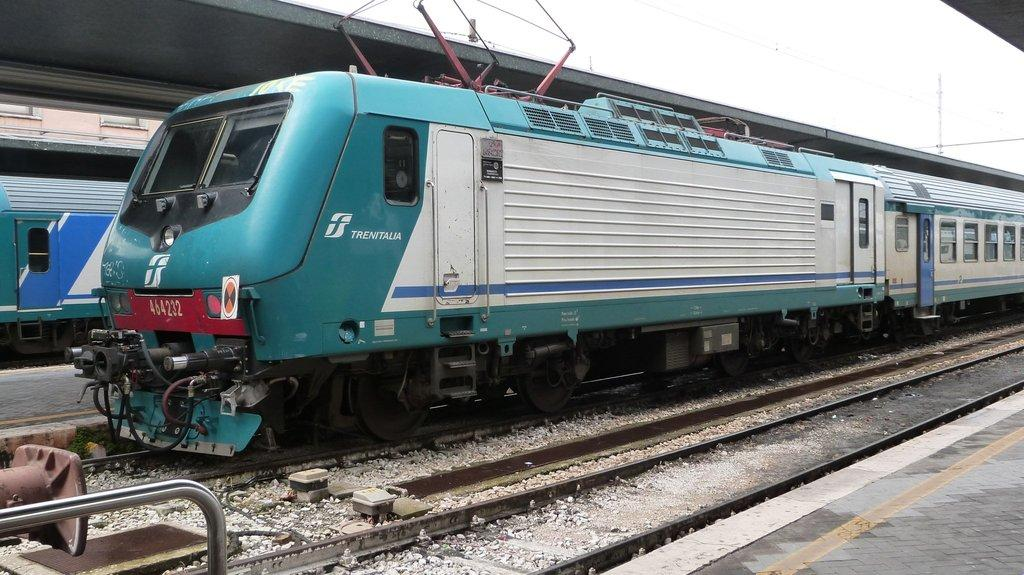<image>
Write a terse but informative summary of the picture. the word trenitalia that is on a train 